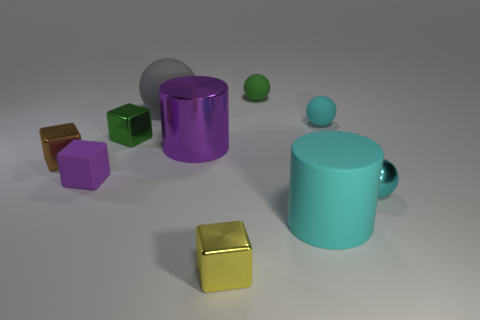Subtract all small yellow cubes. How many cubes are left? 3 Subtract all blocks. How many objects are left? 6 Subtract 4 spheres. How many spheres are left? 0 Subtract all purple cylinders. How many cylinders are left? 1 Subtract all green balls. How many cyan cylinders are left? 1 Subtract all brown shiny cubes. Subtract all purple shiny things. How many objects are left? 8 Add 3 purple cubes. How many purple cubes are left? 4 Add 1 large gray matte things. How many large gray matte things exist? 2 Subtract 0 red cylinders. How many objects are left? 10 Subtract all gray cubes. Subtract all cyan spheres. How many cubes are left? 4 